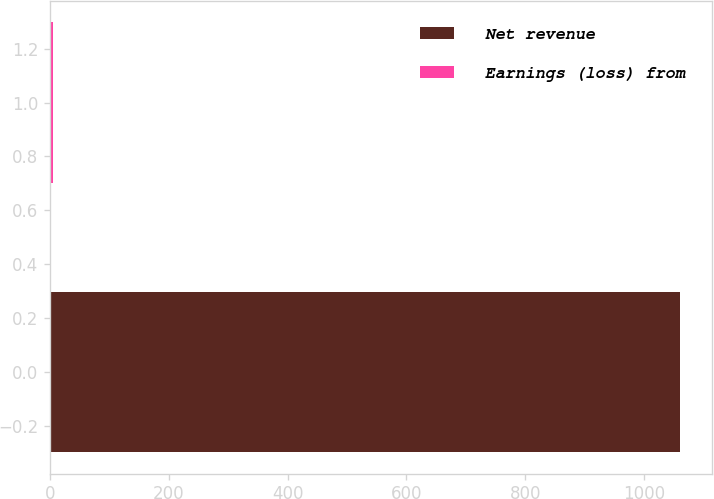Convert chart to OTSL. <chart><loc_0><loc_0><loc_500><loc_500><bar_chart><fcel>Net revenue<fcel>Earnings (loss) from<nl><fcel>1061<fcel>4.6<nl></chart> 